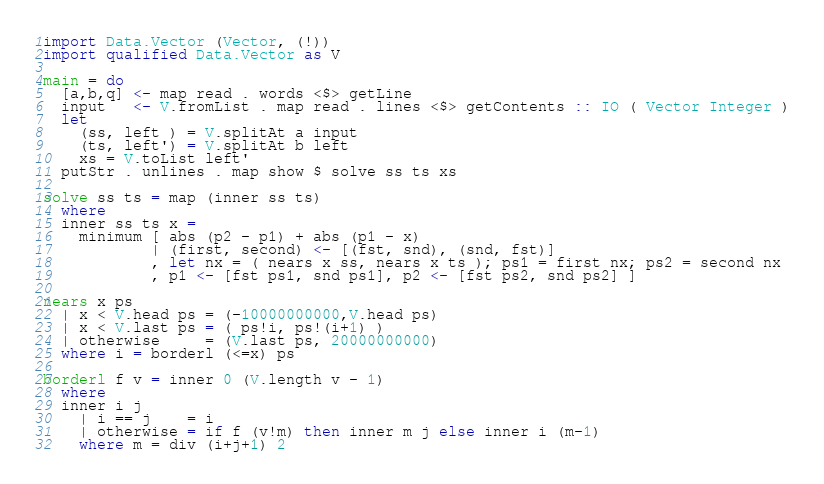<code> <loc_0><loc_0><loc_500><loc_500><_Haskell_>import Data.Vector (Vector, (!))
import qualified Data.Vector as V

main = do
  [a,b,q] <- map read . words <$> getLine
  input   <- V.fromList . map read . lines <$> getContents :: IO ( Vector Integer )
  let
    (ss, left ) = V.splitAt a input
    (ts, left') = V.splitAt b left
    xs = V.toList left'
  putStr . unlines . map show $ solve ss ts xs

solve ss ts = map (inner ss ts)
  where
  inner ss ts x =
    minimum [ abs (p2 - p1) + abs (p1 - x)
            | (first, second) <- [(fst, snd), (snd, fst)]
            , let nx = ( nears x ss, nears x ts ); ps1 = first nx; ps2 = second nx
            , p1 <- [fst ps1, snd ps1], p2 <- [fst ps2, snd ps2] ]

nears x ps
  | x < V.head ps = (-10000000000,V.head ps)
  | x < V.last ps = ( ps!i, ps!(i+1) )
  | otherwise     = (V.last ps, 20000000000)
  where i = borderl (<=x) ps

borderl f v = inner 0 (V.length v - 1)
  where
  inner i j
    | i == j    = i
    | otherwise = if f (v!m) then inner m j else inner i (m-1)
    where m = div (i+j+1) 2
</code> 